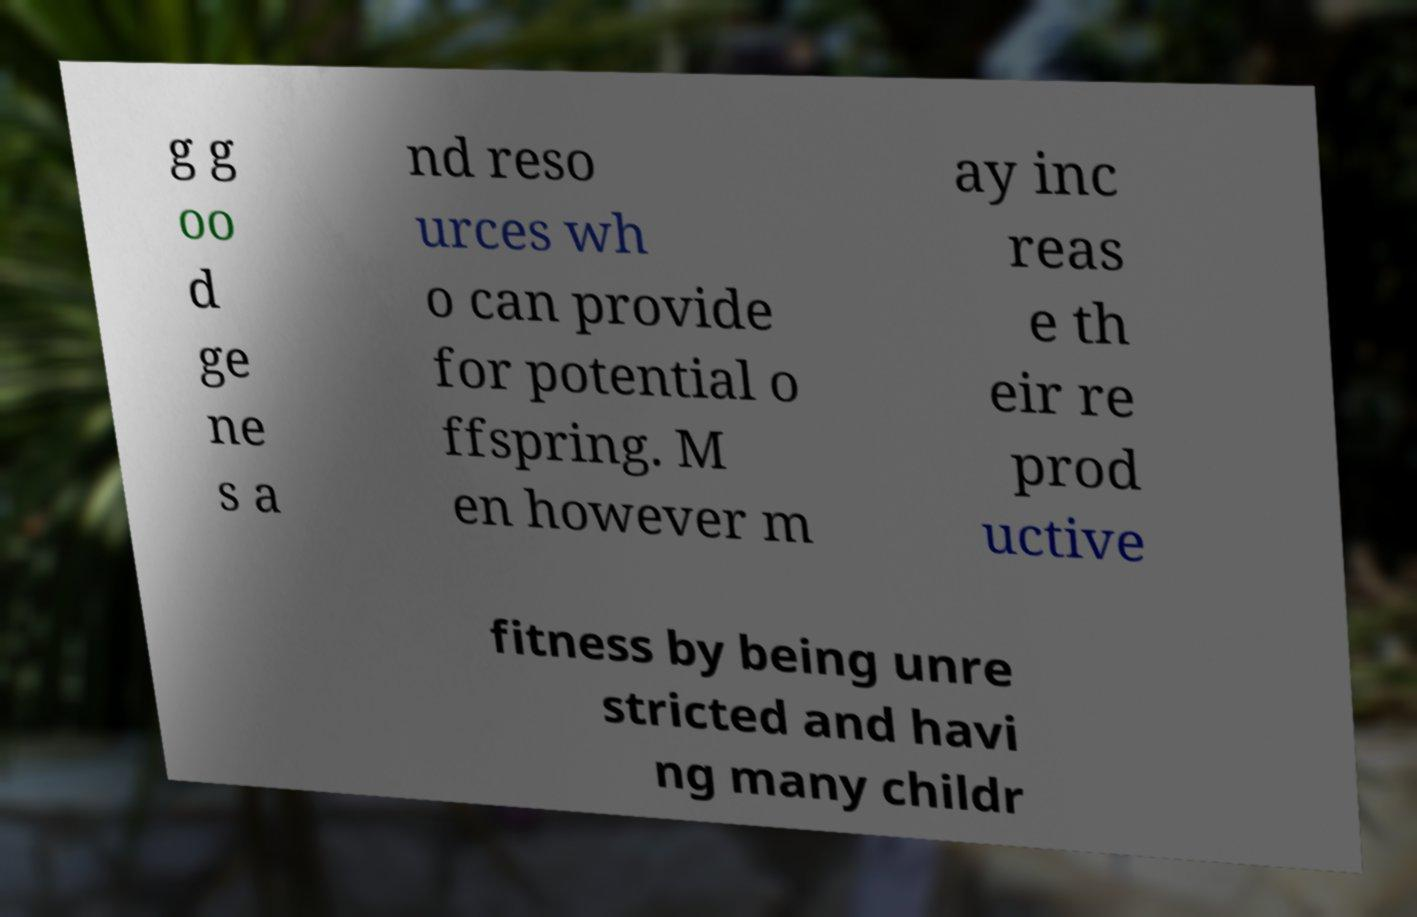Could you assist in decoding the text presented in this image and type it out clearly? g g oo d ge ne s a nd reso urces wh o can provide for potential o ffspring. M en however m ay inc reas e th eir re prod uctive fitness by being unre stricted and havi ng many childr 